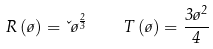<formula> <loc_0><loc_0><loc_500><loc_500>R \left ( \tau \right ) = \kappa \tau ^ { \frac { 2 } { 3 } } \quad T \left ( \tau \right ) = \frac { 3 \tau ^ { 2 } } { 4 }</formula> 